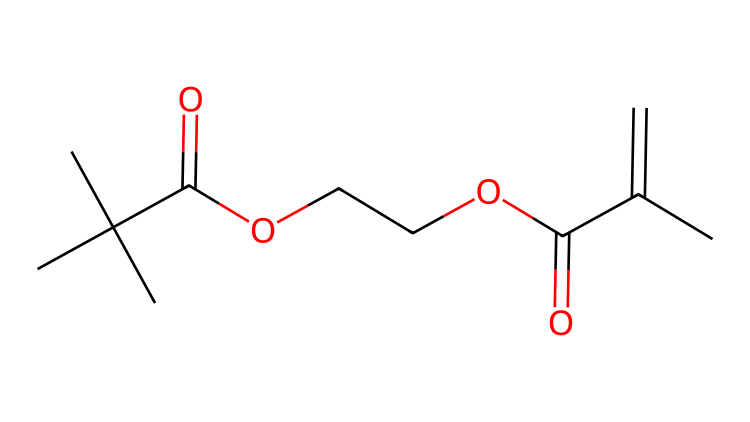What is the total number of carbon atoms in this chemical? To determine the total number of carbon atoms, we count each 'C' present in the SMILES representation. In the given structure, there are 10 carbon atoms.
Answer: 10 How many ester functional groups are present in the structure? The ester functional group is characterized by the presence of -COO- within the chemical structure. In this SMILES, there are two -COO- sequences indicating the presence of two ester groups.
Answer: 2 What is the degree of unsaturation in this chemical? The degree of unsaturation can be calculated by the formula: (C - H/2 + N/2 + 1), where C is the number of carbons and H is the number of hydrogens. From the structure, there are 10 carbons and 14 hydrogens. Using the formula, the degree of unsaturation is 2.
Answer: 2 What type of chemical reaction can this resin undergo when exposed to UV light? Photoreactive chemicals typically undergo polymerization when exposed to UV light, which allows them to cross-link and harden. The presence of alkenes in the structure indicates that it can form bonds during this reaction.
Answer: polymerization Which part of the chemical structure suggests it is used for luxury flooring applications? The presence of dual functionalities like esters and carbon double bonds enhances flexibility and durability, making it suitable for flooring applications. These properties suggest that it is engineered for high-performance uses.
Answer: esters and carbon double bonds Is there any cyclic structure present in this chemical? The provided SMILES does not indicate any cyclic structures, as there are no ring closures specified in the notation. All carbon atoms are part of linear or branched chains.
Answer: no 